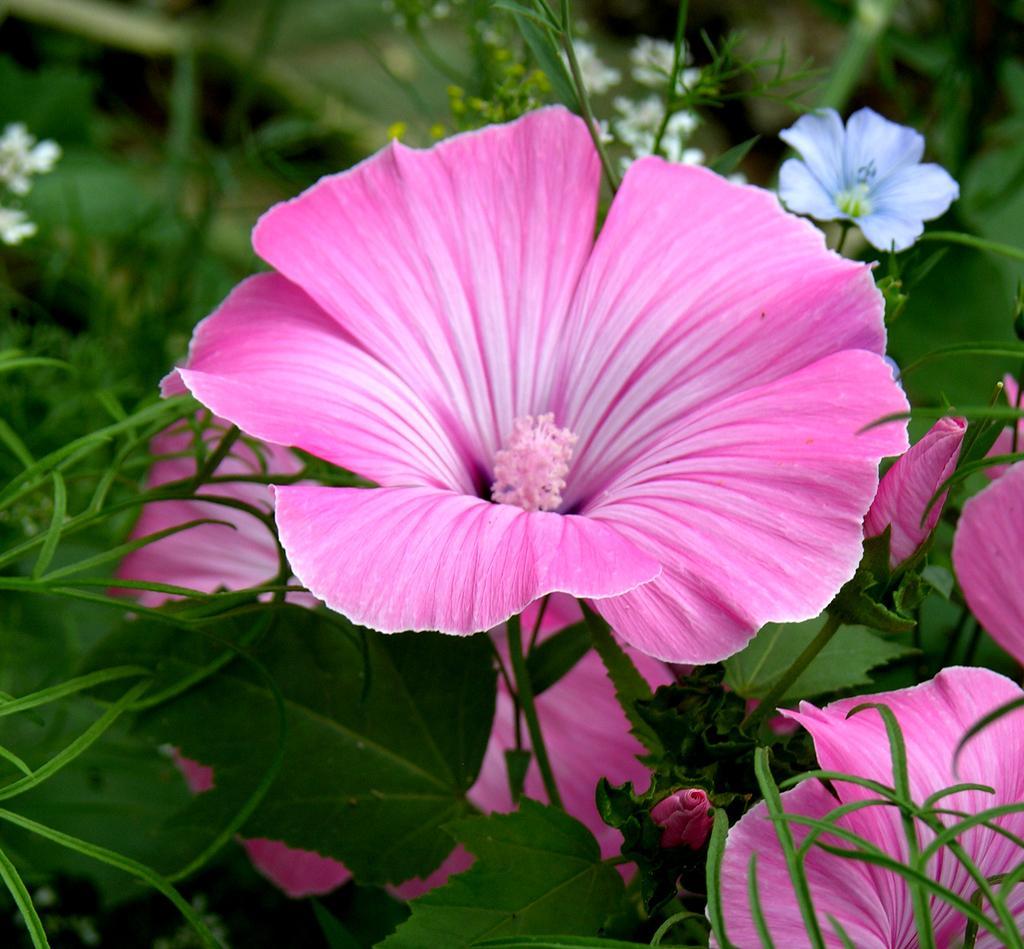How would you summarize this image in a sentence or two? In this image I can see the flowers to the plants. I can see these flowers are in pink, purple and white color. 